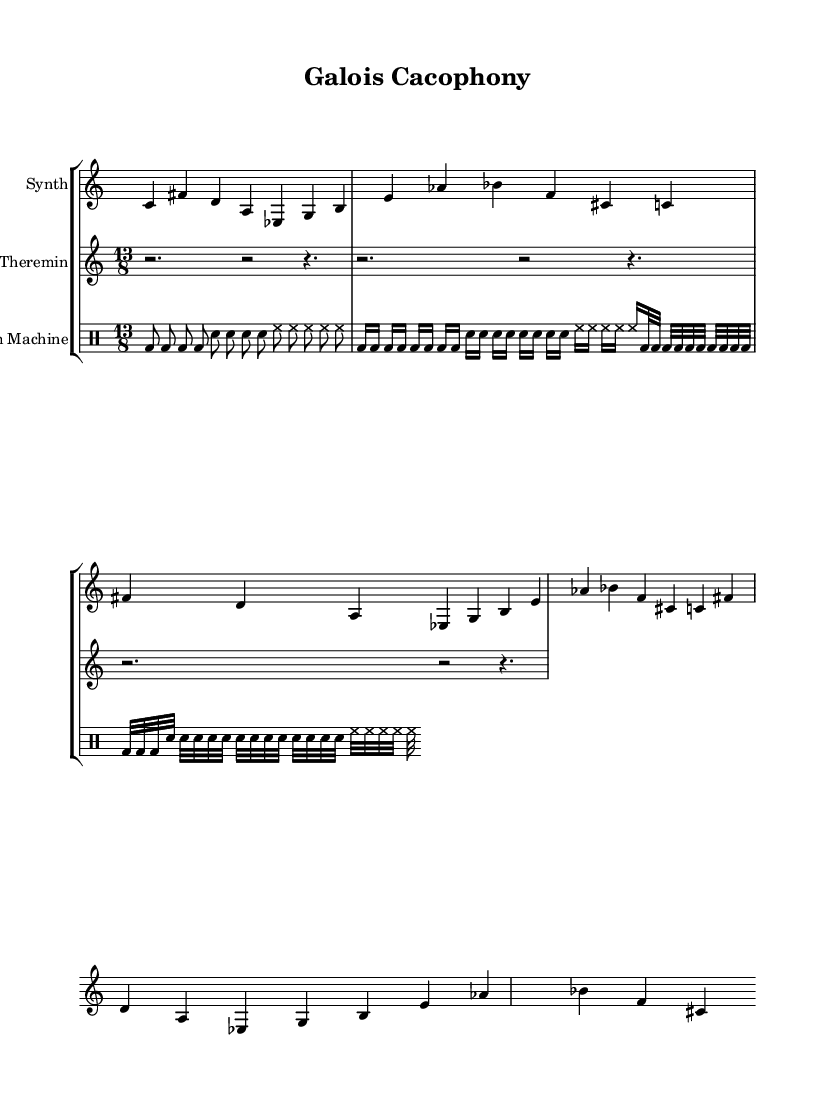What is the time signature of this music? The time signature is 13/8, which is indicated at the beginning of the melody section. It represents the number of beats in each measure (13) and the note value that gets one beat (eighth note).
Answer: 13/8 What instruments are included in this score? The score includes three instruments: a Synth, a Theremin, and a Drum Machine. This is identified by the instrument names labeled at the start of each staff.
Answer: Synth, Theremin, Drum Machine How many repetitions of the melody are there in the Synth part? The melody in the Synth part is written three times sequentially. This is deduced from the repetition of the same set of notes without variation directly beneath each other.
Answer: 3 What type of musical approach is displayed in the drum patterns? The drum patterns are experimental as they incorporate complex rhythms and changing subdivisions (eighth, sixteenth, and thirty-second notes), which is typical for innovative electronic compositions.
Answer: Experimental Is there a key signature present in this piece? There is no key signature presented in the score; this aligns with the characteristics of atonal music, which does not adhere to traditional key signatures. The absence of a key signature indicates atonality.
Answer: No How does the use of rests in the Theremin part contribute to the overall texture? The Theremin part features a series of rests, which creates a sparse texture and allows space for the other instruments to lead. This contrasts with the continuous sound of the Synth, enhancing the overall experimental quality of the piece.
Answer: Sparse texture 